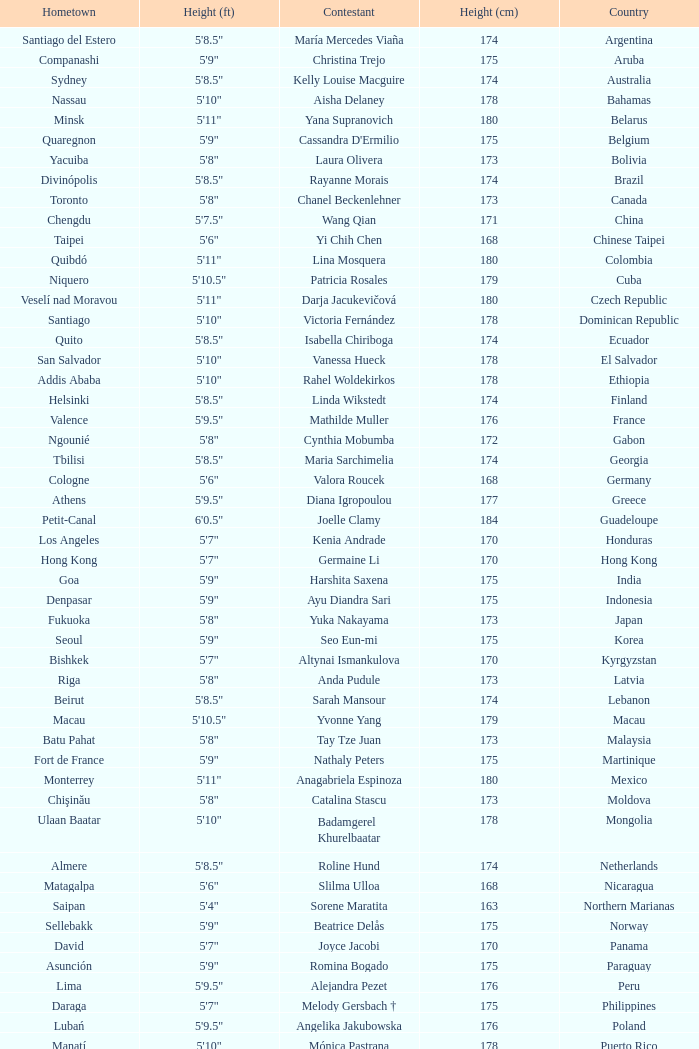What is Cynthia Mobumba's height? 5'8". 